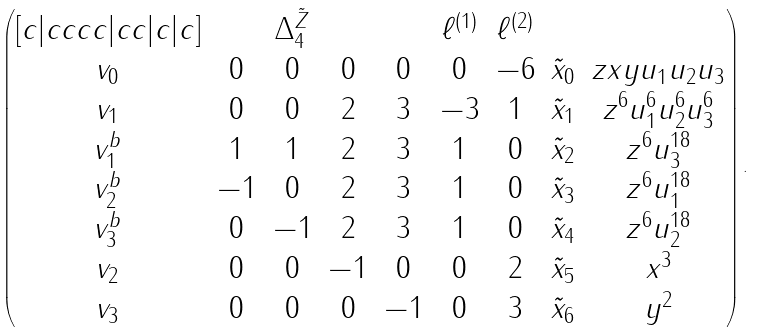<formula> <loc_0><loc_0><loc_500><loc_500>\begin{pmatrix} [ c | c c c c | c c | c | c ] & & \Delta _ { 4 } ^ { \tilde { Z } } & & & \ell ^ { ( 1 ) } & \ell ^ { ( 2 ) } & & \\ v _ { 0 } & 0 & 0 & 0 & 0 & 0 & - 6 & \tilde { x } _ { 0 } & z x y u _ { 1 } u _ { 2 } u _ { 3 } \\ v _ { 1 } & 0 & 0 & 2 & 3 & - 3 & 1 & \tilde { x } _ { 1 } & z ^ { 6 } u _ { 1 } ^ { 6 } u _ { 2 } ^ { 6 } u _ { 3 } ^ { 6 } \\ v ^ { b } _ { 1 } & 1 & 1 & 2 & 3 & 1 & 0 & \tilde { x } _ { 2 } & z ^ { 6 } u _ { 3 } ^ { 1 8 } \\ v ^ { b } _ { 2 } & - 1 & 0 & 2 & 3 & 1 & 0 & \tilde { x } _ { 3 } & z ^ { 6 } u _ { 1 } ^ { 1 8 } \\ v ^ { b } _ { 3 } & 0 & - 1 & 2 & 3 & 1 & 0 & \tilde { x } _ { 4 } & z ^ { 6 } u _ { 2 } ^ { 1 8 } \\ v _ { 2 } & 0 & 0 & - 1 & 0 & 0 & 2 & \tilde { x } _ { 5 } & x ^ { 3 } \\ v _ { 3 } & 0 & 0 & 0 & - 1 & 0 & 3 & \tilde { x } _ { 6 } & y ^ { 2 } \end{pmatrix} .</formula> 